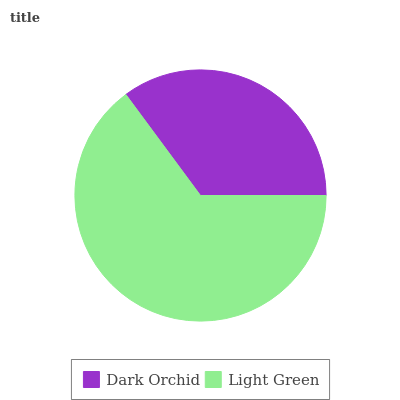Is Dark Orchid the minimum?
Answer yes or no. Yes. Is Light Green the maximum?
Answer yes or no. Yes. Is Light Green the minimum?
Answer yes or no. No. Is Light Green greater than Dark Orchid?
Answer yes or no. Yes. Is Dark Orchid less than Light Green?
Answer yes or no. Yes. Is Dark Orchid greater than Light Green?
Answer yes or no. No. Is Light Green less than Dark Orchid?
Answer yes or no. No. Is Light Green the high median?
Answer yes or no. Yes. Is Dark Orchid the low median?
Answer yes or no. Yes. Is Dark Orchid the high median?
Answer yes or no. No. Is Light Green the low median?
Answer yes or no. No. 